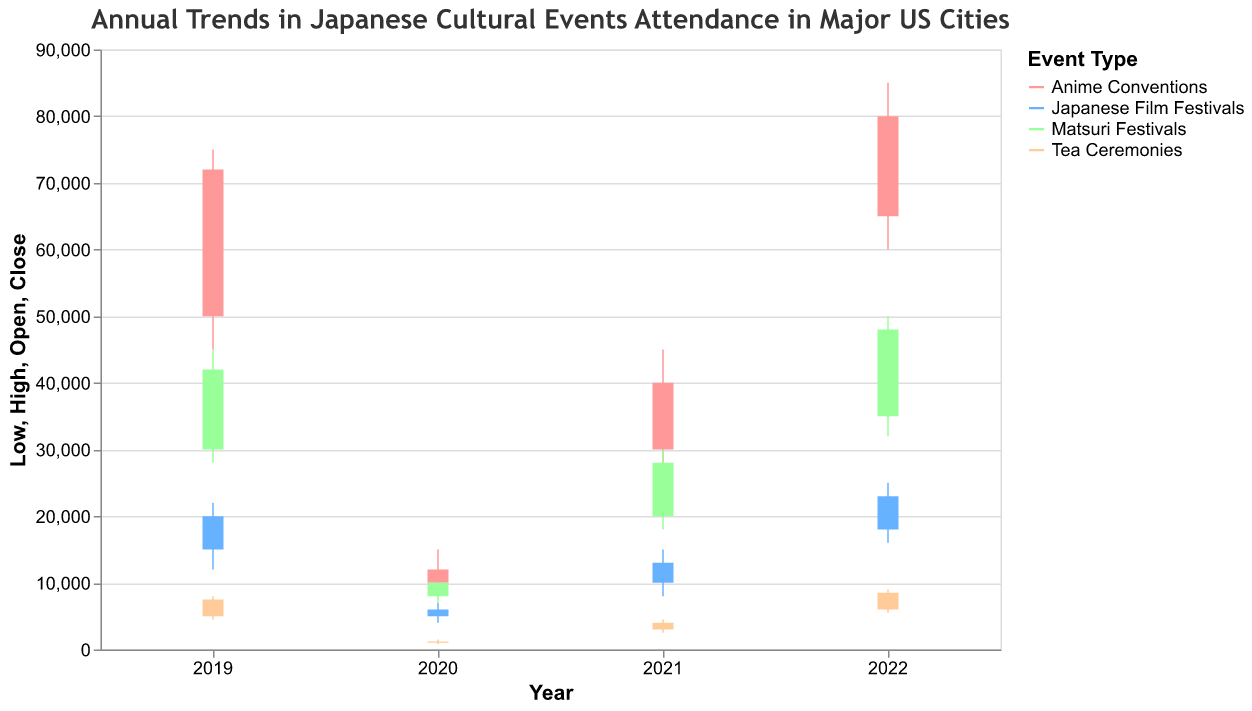How did the attendance at Anime Conventions change from 2020 to 2021? The attendance at Anime Conventions in 2020 opened at 10,000 and closed at 12,000. In 2021, it opened at 30,000 and closed at 40,000, indicating a significant increase.
Answer: A significant increase Which event type had the highest increase in attendance from 2021 to 2022? To find the event type with the highest increase, compare the closing values for each event type from 2021 to 2022. Anime Conventions increased from 40,000 to 80,000, Japanese Film Festivals from 13,000 to 23,000, Matsuri Festivals from 28,000 to 48,000, and Tea Ceremonies from 4,000 to 8,500. The highest increase is in Anime Conventions.
Answer: Anime Conventions In which year did Tea Ceremonies have the lowest attendance and what was the value? Look at the closing values for Tea Ceremonies across the years. In 2020, the closing value was 1,200, which is the lowest.
Answer: 2020, 1,200 What was the difference between the highest and lowest attendance for Matsuri Festivals in 2019? The highest attendance was 45,000 and the lowest was 28,000. The difference is 45,000 - 28,000 = 17,000.
Answer: 17,000 Compare the opening and closing attendance figures for Japanese Film Festivals in 2022. Was there an increase or decrease? The opening figure for Japanese Film Festivals in 2022 was 18,000 and the closing was 23,000. Since 23,000 is greater than 18,000, there was an increase.
Answer: Increase How did the range of attendance (difference between high and low) for Tea Ceremonies change from 2020 to 2022? In 2020, the range was 1,500 - 800 = 700. In 2022, the range was 9,000 - 5,500 = 3,500. The range increased from 700 to 3,500.
Answer: 3,500 (increased) Which event type had the smallest attendance increase from 2019 to 2022? Compare the closing values for each event type from 2019 to 2022. Anime Conventions increased from 72,000 to 80,000, Japanese Film Festivals from 20,000 to 23,000, Matsuri Festivals from 42,000 to 48,000, and Tea Ceremonies from 7,500 to 8,500. The smallest increase is in Japanese Film Festivals.
Answer: Japanese Film Festivals 